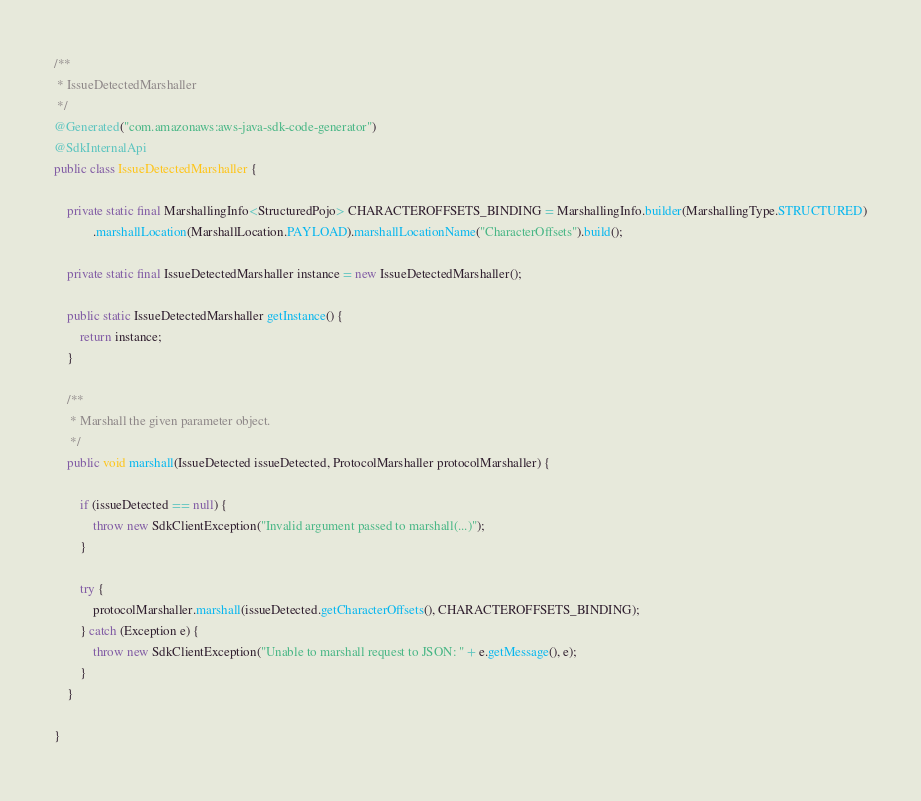<code> <loc_0><loc_0><loc_500><loc_500><_Java_>
/**
 * IssueDetectedMarshaller
 */
@Generated("com.amazonaws:aws-java-sdk-code-generator")
@SdkInternalApi
public class IssueDetectedMarshaller {

    private static final MarshallingInfo<StructuredPojo> CHARACTEROFFSETS_BINDING = MarshallingInfo.builder(MarshallingType.STRUCTURED)
            .marshallLocation(MarshallLocation.PAYLOAD).marshallLocationName("CharacterOffsets").build();

    private static final IssueDetectedMarshaller instance = new IssueDetectedMarshaller();

    public static IssueDetectedMarshaller getInstance() {
        return instance;
    }

    /**
     * Marshall the given parameter object.
     */
    public void marshall(IssueDetected issueDetected, ProtocolMarshaller protocolMarshaller) {

        if (issueDetected == null) {
            throw new SdkClientException("Invalid argument passed to marshall(...)");
        }

        try {
            protocolMarshaller.marshall(issueDetected.getCharacterOffsets(), CHARACTEROFFSETS_BINDING);
        } catch (Exception e) {
            throw new SdkClientException("Unable to marshall request to JSON: " + e.getMessage(), e);
        }
    }

}
</code> 